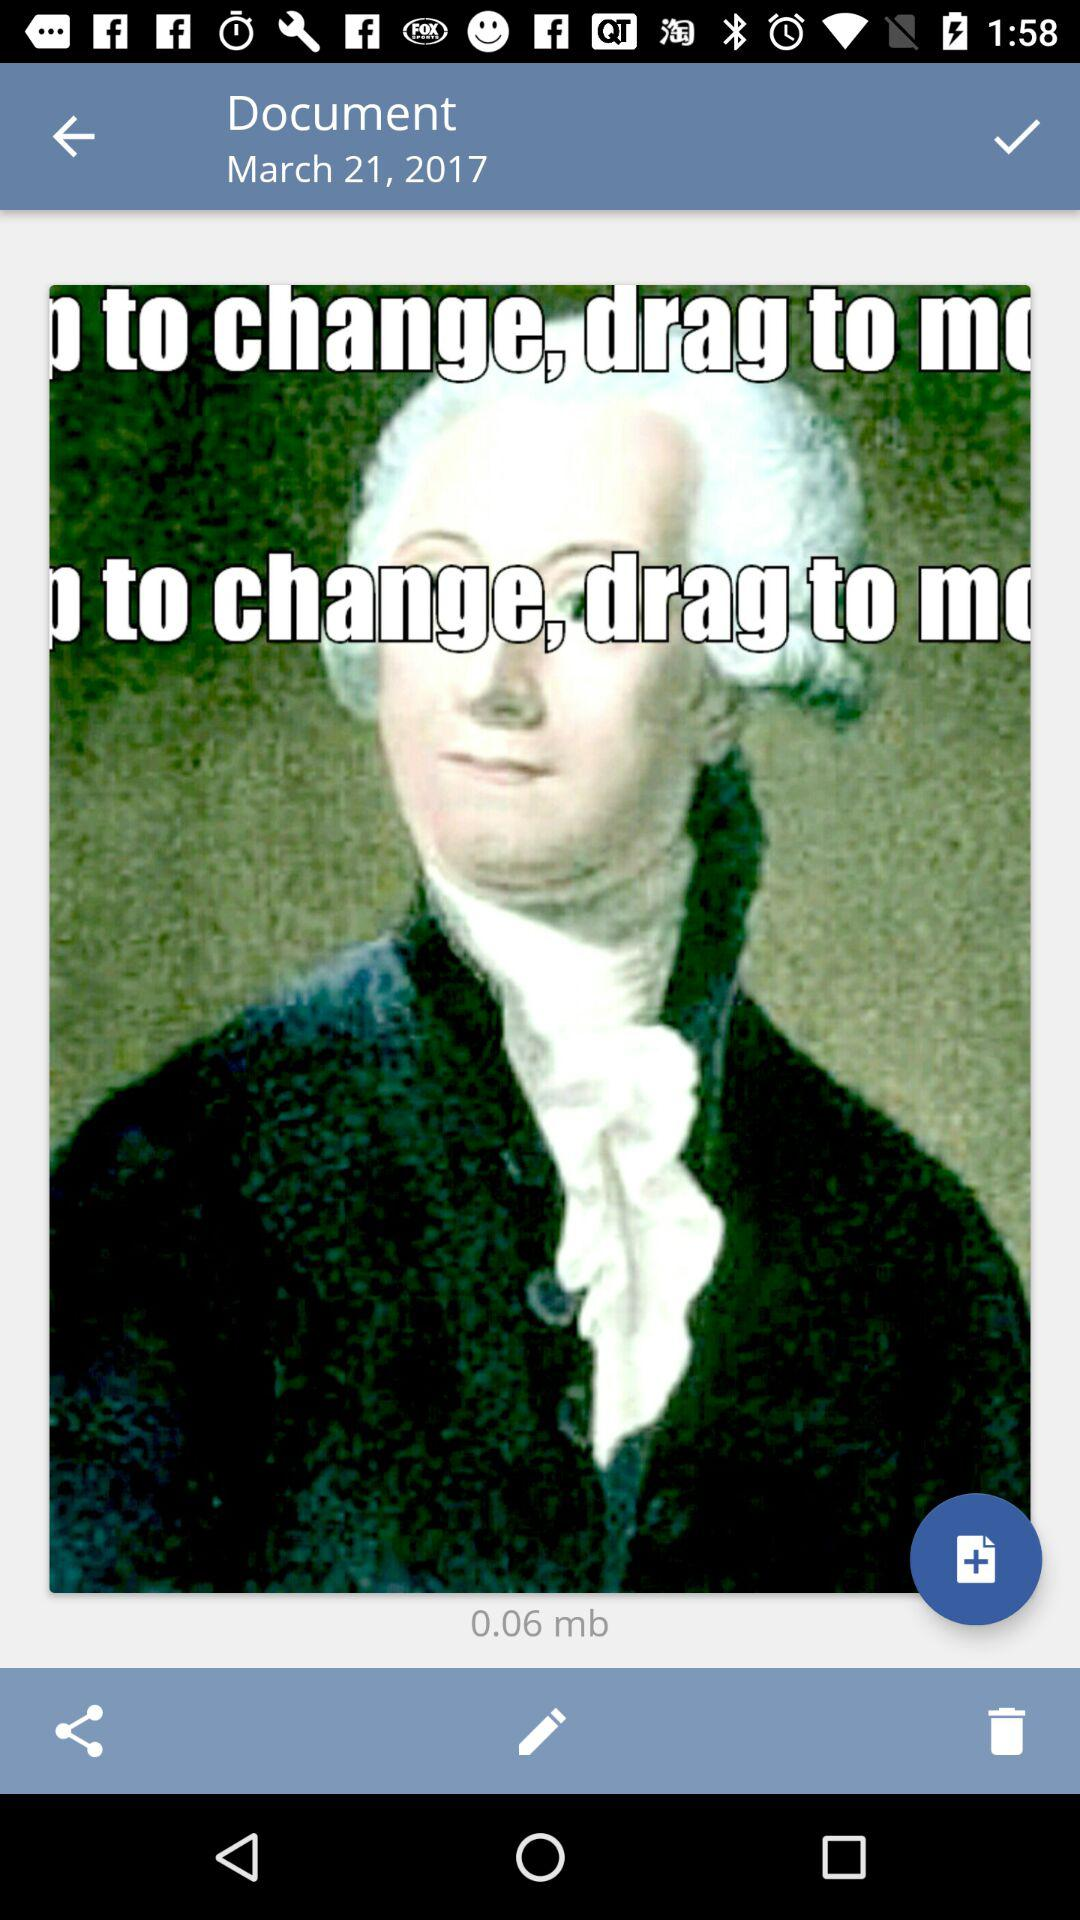How many pictures have been deleted?
When the provided information is insufficient, respond with <no answer>. <no answer> 